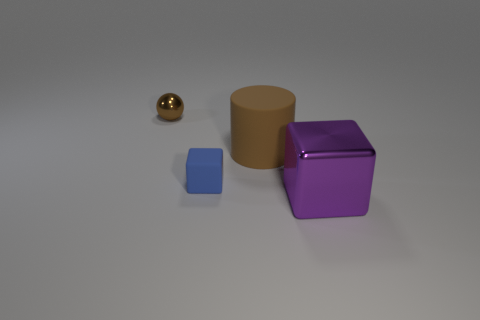Does the block behind the purple object have the same size as the brown matte cylinder?
Offer a very short reply. No. Is there a big brown cube made of the same material as the tiny blue thing?
Keep it short and to the point. No. What number of things are either brown objects on the left side of the metal block or big purple objects?
Your answer should be very brief. 3. Are there any spheres?
Offer a terse response. Yes. What shape is the thing that is to the right of the tiny blue cube and behind the blue block?
Provide a short and direct response. Cylinder. There is a metal thing behind the large purple thing; what is its size?
Your answer should be very brief. Small. There is a metal object that is behind the brown matte cylinder; is it the same color as the rubber cylinder?
Offer a very short reply. Yes. How many other blue things are the same shape as the tiny blue matte object?
Make the answer very short. 0. How many objects are objects that are behind the large cylinder or brown things left of the small blue matte block?
Make the answer very short. 1. How many green things are either big shiny cylinders or large matte cylinders?
Make the answer very short. 0. 